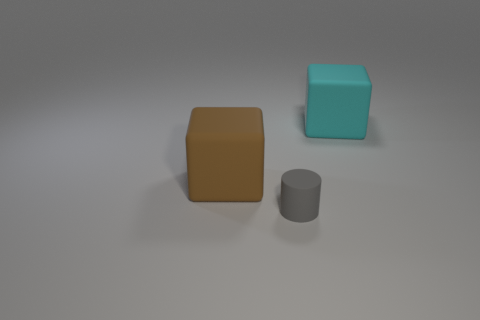Are there any other things that have the same shape as the tiny gray object?
Give a very brief answer. No. Is there anything else that is the same size as the gray object?
Provide a short and direct response. No. What number of blocks are big objects or brown objects?
Give a very brief answer. 2. Are there an equal number of cyan blocks that are to the right of the tiny rubber cylinder and cyan blocks?
Your answer should be very brief. Yes. What number of objects are either large things that are on the left side of the cyan thing or gray metallic spheres?
Keep it short and to the point. 1. What number of things are red shiny cylinders or large rubber cubes that are behind the brown matte cube?
Keep it short and to the point. 1. How many cylinders are behind the large matte block to the right of the object left of the rubber cylinder?
Your response must be concise. 0. There is a cyan block that is the same size as the brown rubber thing; what is its material?
Keep it short and to the point. Rubber. Are there any matte cubes of the same size as the cyan matte object?
Your answer should be very brief. Yes. What is the color of the tiny matte thing?
Provide a succinct answer. Gray. 